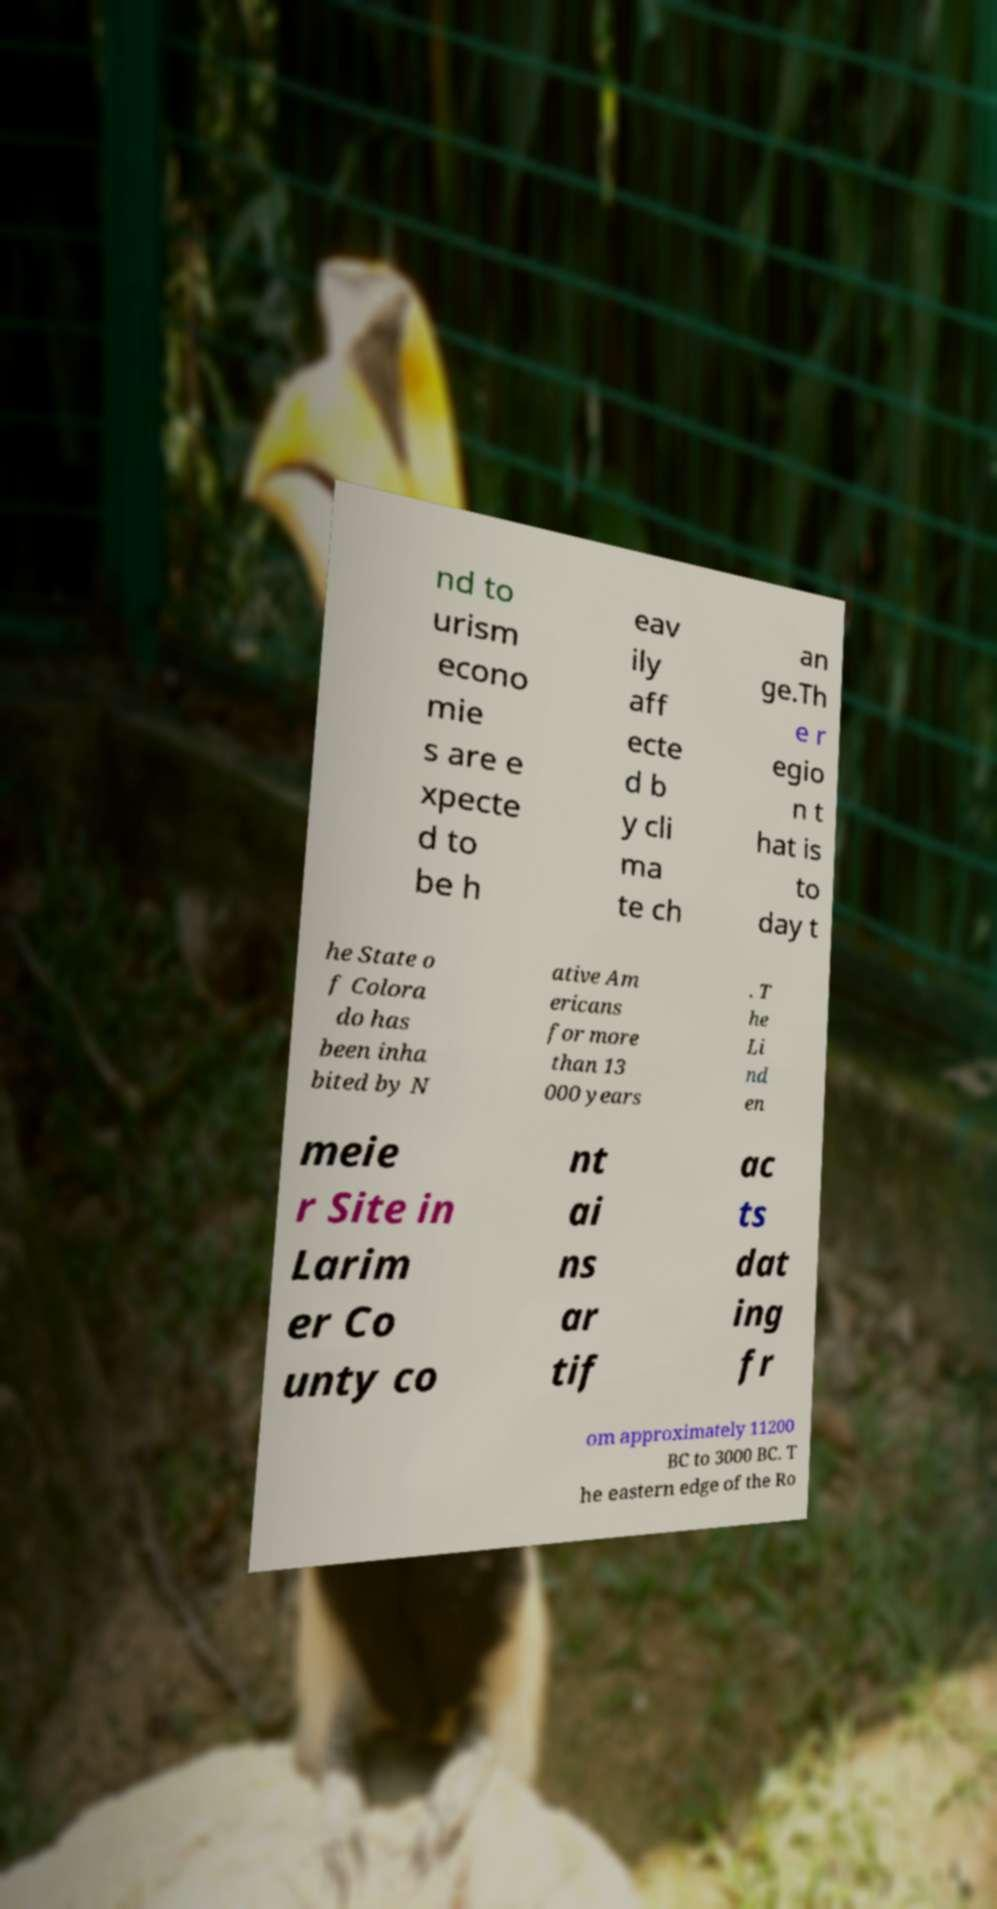I need the written content from this picture converted into text. Can you do that? nd to urism econo mie s are e xpecte d to be h eav ily aff ecte d b y cli ma te ch an ge.Th e r egio n t hat is to day t he State o f Colora do has been inha bited by N ative Am ericans for more than 13 000 years . T he Li nd en meie r Site in Larim er Co unty co nt ai ns ar tif ac ts dat ing fr om approximately 11200 BC to 3000 BC. T he eastern edge of the Ro 